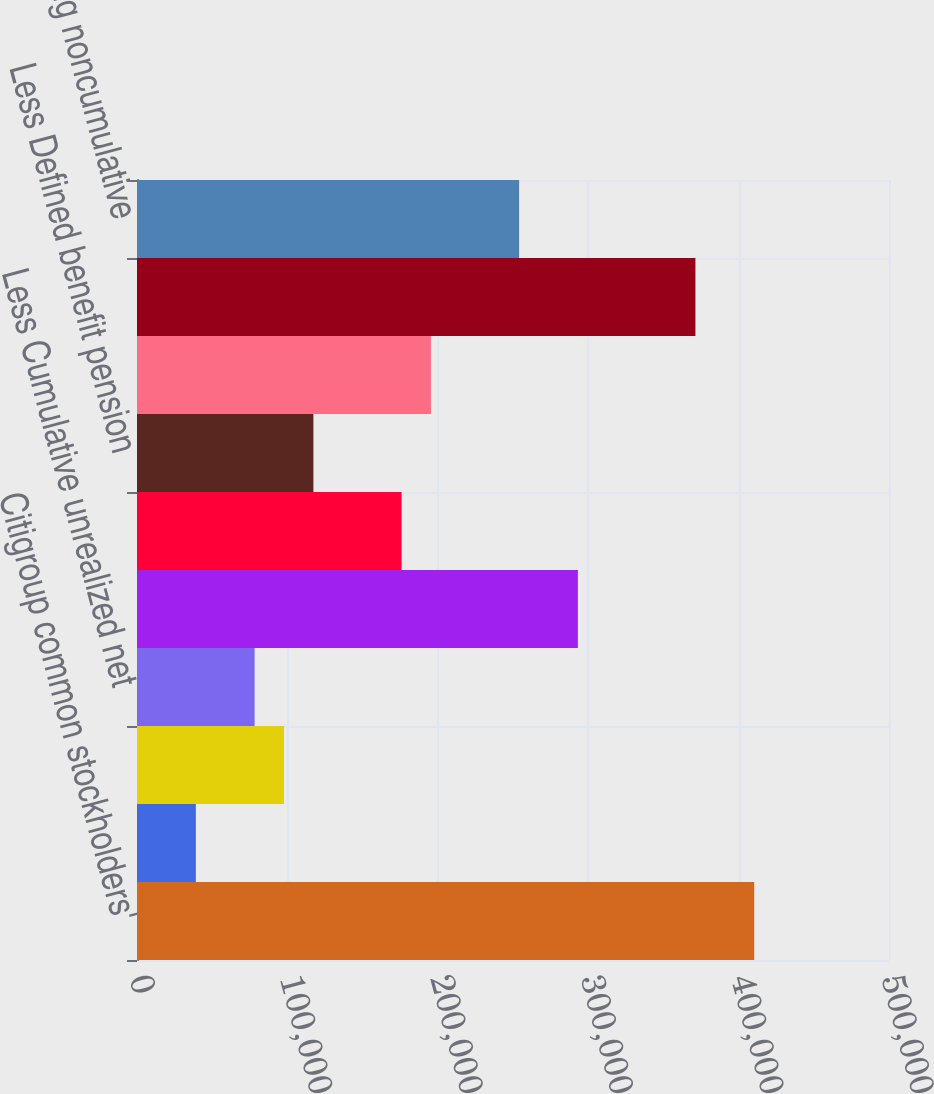Convert chart. <chart><loc_0><loc_0><loc_500><loc_500><bar_chart><fcel>Citigroup common stockholders'<fcel>Add Qualifying noncontrolling<fcel>Less Accumulated net<fcel>Less Cumulative unrealized net<fcel>Goodwill net of related DTLs<fcel>Identifiable intangible assets<fcel>Less Defined benefit pension<fcel>Less DTAs arising from net<fcel>Total Common Equity Tier 1<fcel>Qualifying noncumulative<nl><fcel>410364<fcel>39132<fcel>97747.5<fcel>78209<fcel>293132<fcel>175902<fcel>117286<fcel>195440<fcel>371286<fcel>254056<nl></chart> 